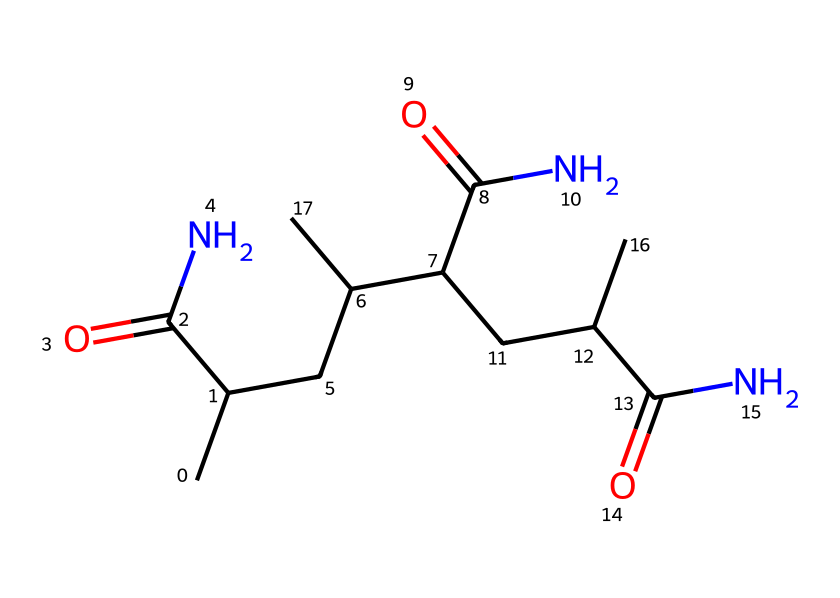What is the molecular formula of the compound? From the SMILES notation, we can analyze the structure to determine the number of each type of atom present. Counting the carbon (C), hydrogen (H), oxygen (O), and nitrogen (N) atoms, we find: 15 carbon, 30 hydrogen, 6 oxygen, and 3 nitrogen. Thus, the molecular formula is C15H30N3O6.
Answer: C15H30N3O6 How many nitrogen atoms are in the structure? By looking at the SMILES representation, we can identify each nitrogen atom represented by 'N' in the formula. There are three occurrences of 'N', indicating that there are three nitrogen atoms present.
Answer: 3 What type of functional groups are present in this chemical? On analyzing the SMILES, we can identify the presence of amide groups (due to the C(=O)N structure) and possibly alcohol groups (if there are C--O bonds). The presence of multiple C(=O)N suggests that it has multiple amide groups. This indicates that amide functional groups are the primary functional group type in this chemical.
Answer: amide What is the primary interaction type in polyacrylamide-based soil stabilizers? Polyacrylamide is known for its ability to form hydrogen bonds due to the presence of amide groups that can interact with water and soil particles. Therefore, the dominant interaction type in these stabilizers is hydrogen bonding.
Answer: hydrogen bonding Does this compound exhibit shear-thinning behavior? Non-Newtonian fluids, particularly those containing polyacrylamide, are known for their shear-thinning behavior where viscosity decreases with increased shear rate. Analyzing the structure indicates that it is indeed a polyacrylamide, thus confirming that it exhibits shear-thinning behavior.
Answer: yes 